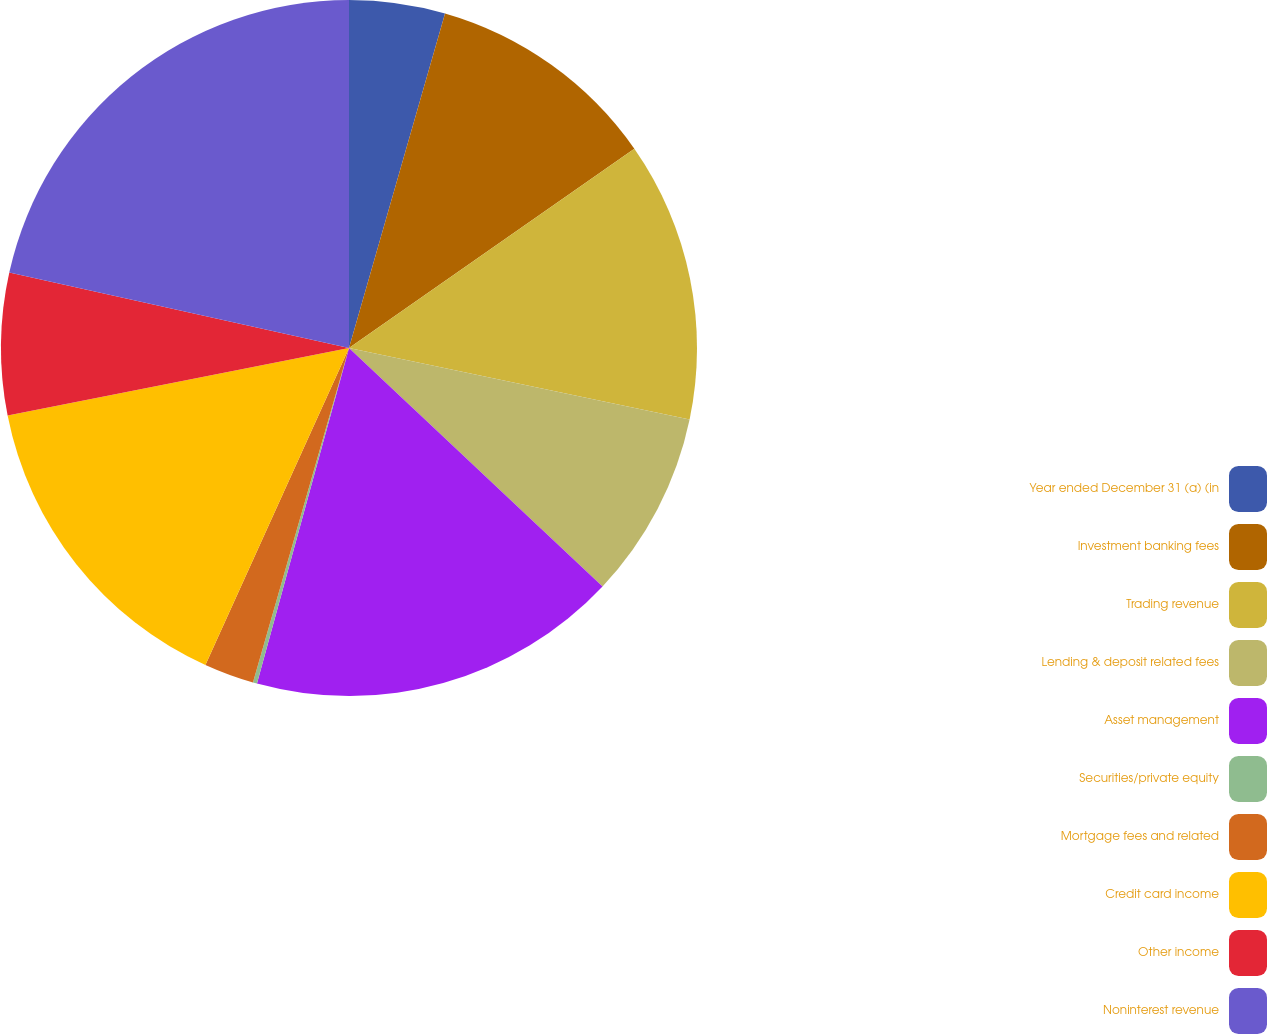<chart> <loc_0><loc_0><loc_500><loc_500><pie_chart><fcel>Year ended December 31 (a) (in<fcel>Investment banking fees<fcel>Trading revenue<fcel>Lending & deposit related fees<fcel>Asset management<fcel>Securities/private equity<fcel>Mortgage fees and related<fcel>Credit card income<fcel>Other income<fcel>Noninterest revenue<nl><fcel>4.45%<fcel>10.85%<fcel>12.99%<fcel>8.72%<fcel>17.25%<fcel>0.19%<fcel>2.32%<fcel>15.12%<fcel>6.59%<fcel>21.52%<nl></chart> 